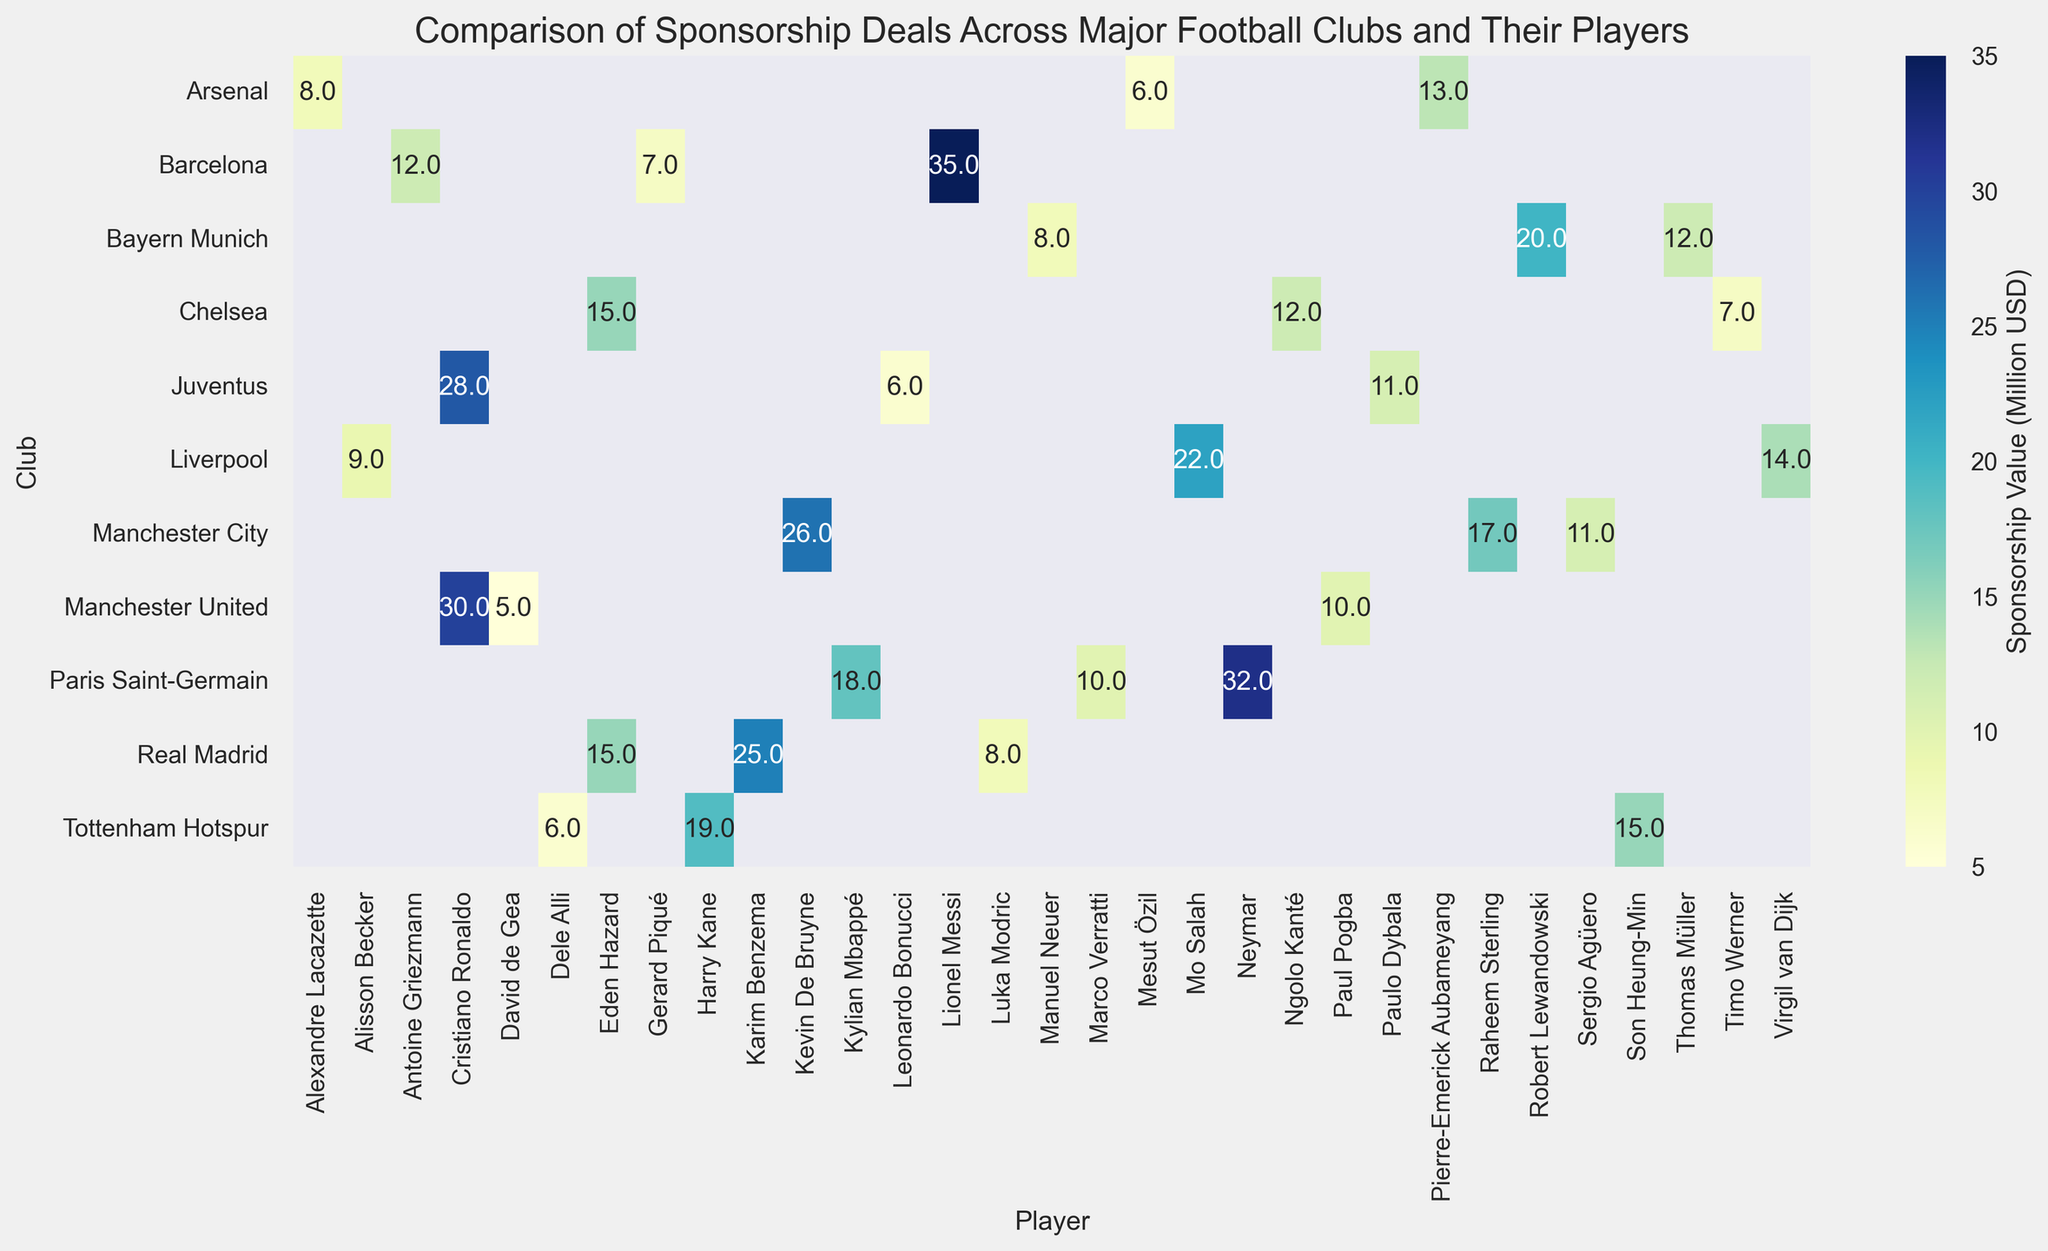Which player has the highest sponsorship deal? The figure shows the highest value in the heatmap. The player with the largest sponsorship deal is found by identifying the highest annotated value.
Answer: Lionel Messi Which club has the lowest sponsorship deal with their players? By examining the heatmap, the club with the lowest individual value highlighted would indicate the lowest sponsorship deal.
Answer: Real Madrid (Luka Modric with $8 Million) Who has the highest sponsorship value at Paris Saint-Germain? Look at the row corresponding to Paris Saint-Germain and identify the highest annotated value within it.
Answer: Neymar What is the difference in sponsorship value between the highest-valued player in Barcelona and the lowest-valued player in Manchester United? The highest value in Barcelona is 35 (Lionel Messi) and the lowest in Manchester United is 5 (David de Gea). The difference is calculated as 35 - 5.
Answer: 30 Which club has the widest range of sponsorship values among its players? Identify the range (highest value minus lowest value) for each club and compare. For Manchester United, it's 30-5=25; Real Madrid, it's 25-8=17; Barcelona, it's 35-7=28; and so on. The largest range indicates the answer.
Answer: Manchester United How does the average sponsorship value of players in Liverpool compare to that in Chelsea? Calculate the average for each club: Liverpool (Sum of values is 14+22+9 = 45, Average is 45/3 = 15) and Chelsea (Sum of values is 15+12+7 = 34, Average is 34/3 = 11.33). Compare the averages.
Answer: Liverpool has a higher average sponsorship value Who is the only player listed twice in the plot and what are the associated clubs? Identify the player name that appears more than once within the plot annotations and the corresponding clubs.
Answer: Eden Hazard (Real Madrid and Chelsea) Which clubs have at least one player with a sponsorship deal over $20 Million? Visually scan the figure and note clubs that have any value over 20.
Answer: Manchester United, Real Madrid, Barcelona, Paris Saint-Germain, Bayern Munich, Manchester City, Liverpool What is the combined sponsorship value of all players in Juventus? Add the sponsorship values of all players in Juventus: 28 (Cristiano Ronaldo) + 11 (Paulo Dybala) + 6 (Leonardo Bonucci) = 45.
Answer: 45 Which has more players with a sponsorship value over $20 Million - players from English clubs or non-English clubs? Identify and count all players over $20 Million from both groups. English clubs: Manchester United (Cristiano Ronaldo), Liverpool (Mo Salah), Manchester City (Kevin De Bruyne). Non-English clubs: Barcelona (Lionel Messi), Paris Saint-Germain (Neymar), Bayern Munich (Robert Lewandowski), Real Madrid (Karim Benzema). Compare counts.
Answer: Non-English clubs 